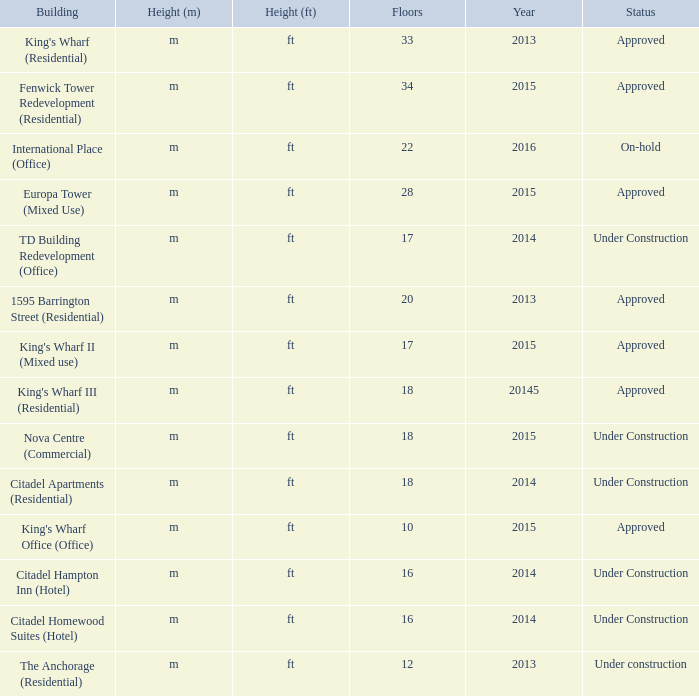What is the status of the building with less than 18 floors and later than 2013? Under Construction, Approved, Approved, Under Construction, Under Construction. 